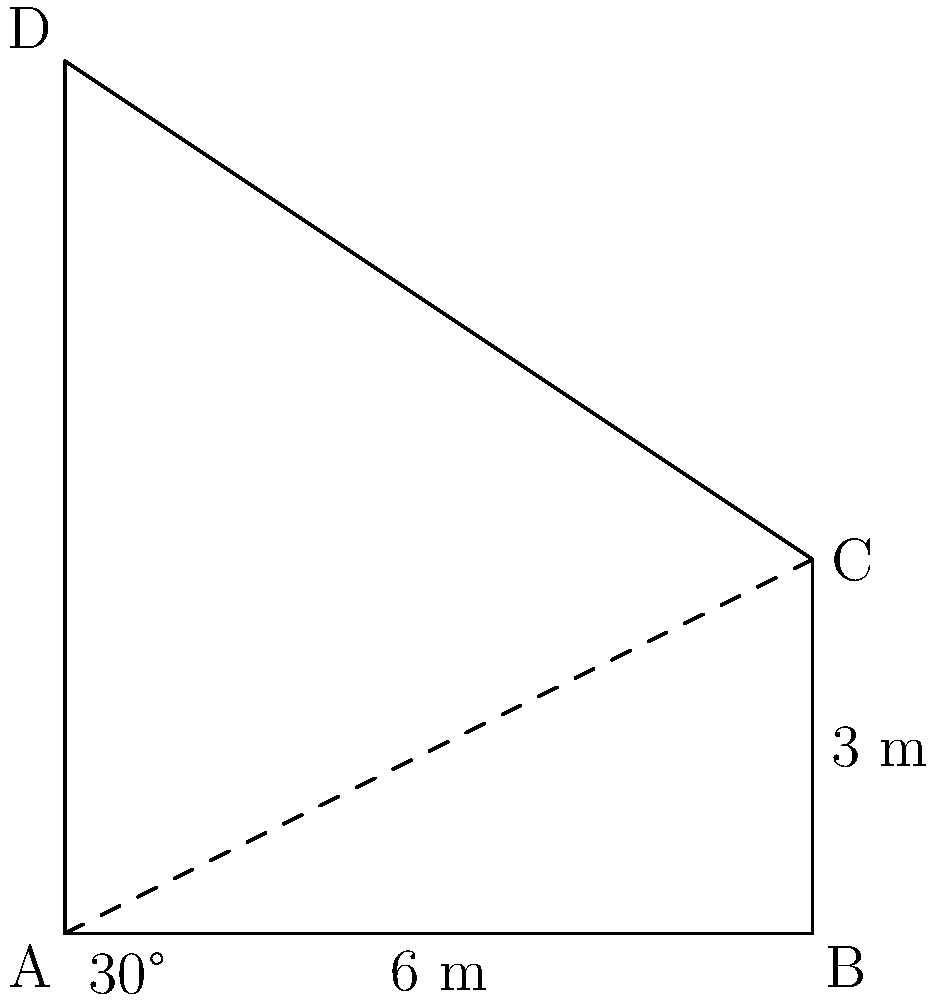In Angela Carter's Gothic-inspired novel "Nights at the Circus," the protagonist Sophie Fevvers encounters a mysterious castle. The castle's spire casts a shadow that stretches 6 meters along the ground. If the angle of elevation of the sun is 30°, and the base of the spire is 3 meters wide, what is the height of the spire? Round your answer to the nearest tenth of a meter. Let's approach this step-by-step:

1) First, we need to identify the relevant trigonometric ratio. We're looking for the height, which is the opposite side to the 30° angle, and we know the adjacent side (the shadow length). This suggests we should use the tangent ratio.

2) The tangent of 30° is equal to the opposite side (height) divided by the adjacent side (shadow length):

   $\tan 30° = \frac{\text{height}}{\text{shadow length}}$

3) We know that $\tan 30° = \frac{1}{\sqrt{3}} \approx 0.577$

4) Let's call the height of the triangle $h$. We can set up the equation:

   $0.577 = \frac{h}{6}$

5) Solving for $h$:
   
   $h = 6 * 0.577 = 3.462$ meters

6) However, this is the height of the triangle, not the spire. We need to add the width of the base (3 meters) to get the total height of the spire:

   $\text{Spire height} = 3.462 + 3 = 6.462$ meters

7) Rounding to the nearest tenth:

   $\text{Spire height} \approx 6.5$ meters

This Gothic spire, reminiscent of the fantastical architecture in Carter's magical realist works, towers approximately 6.5 meters into the sky.
Answer: 6.5 meters 